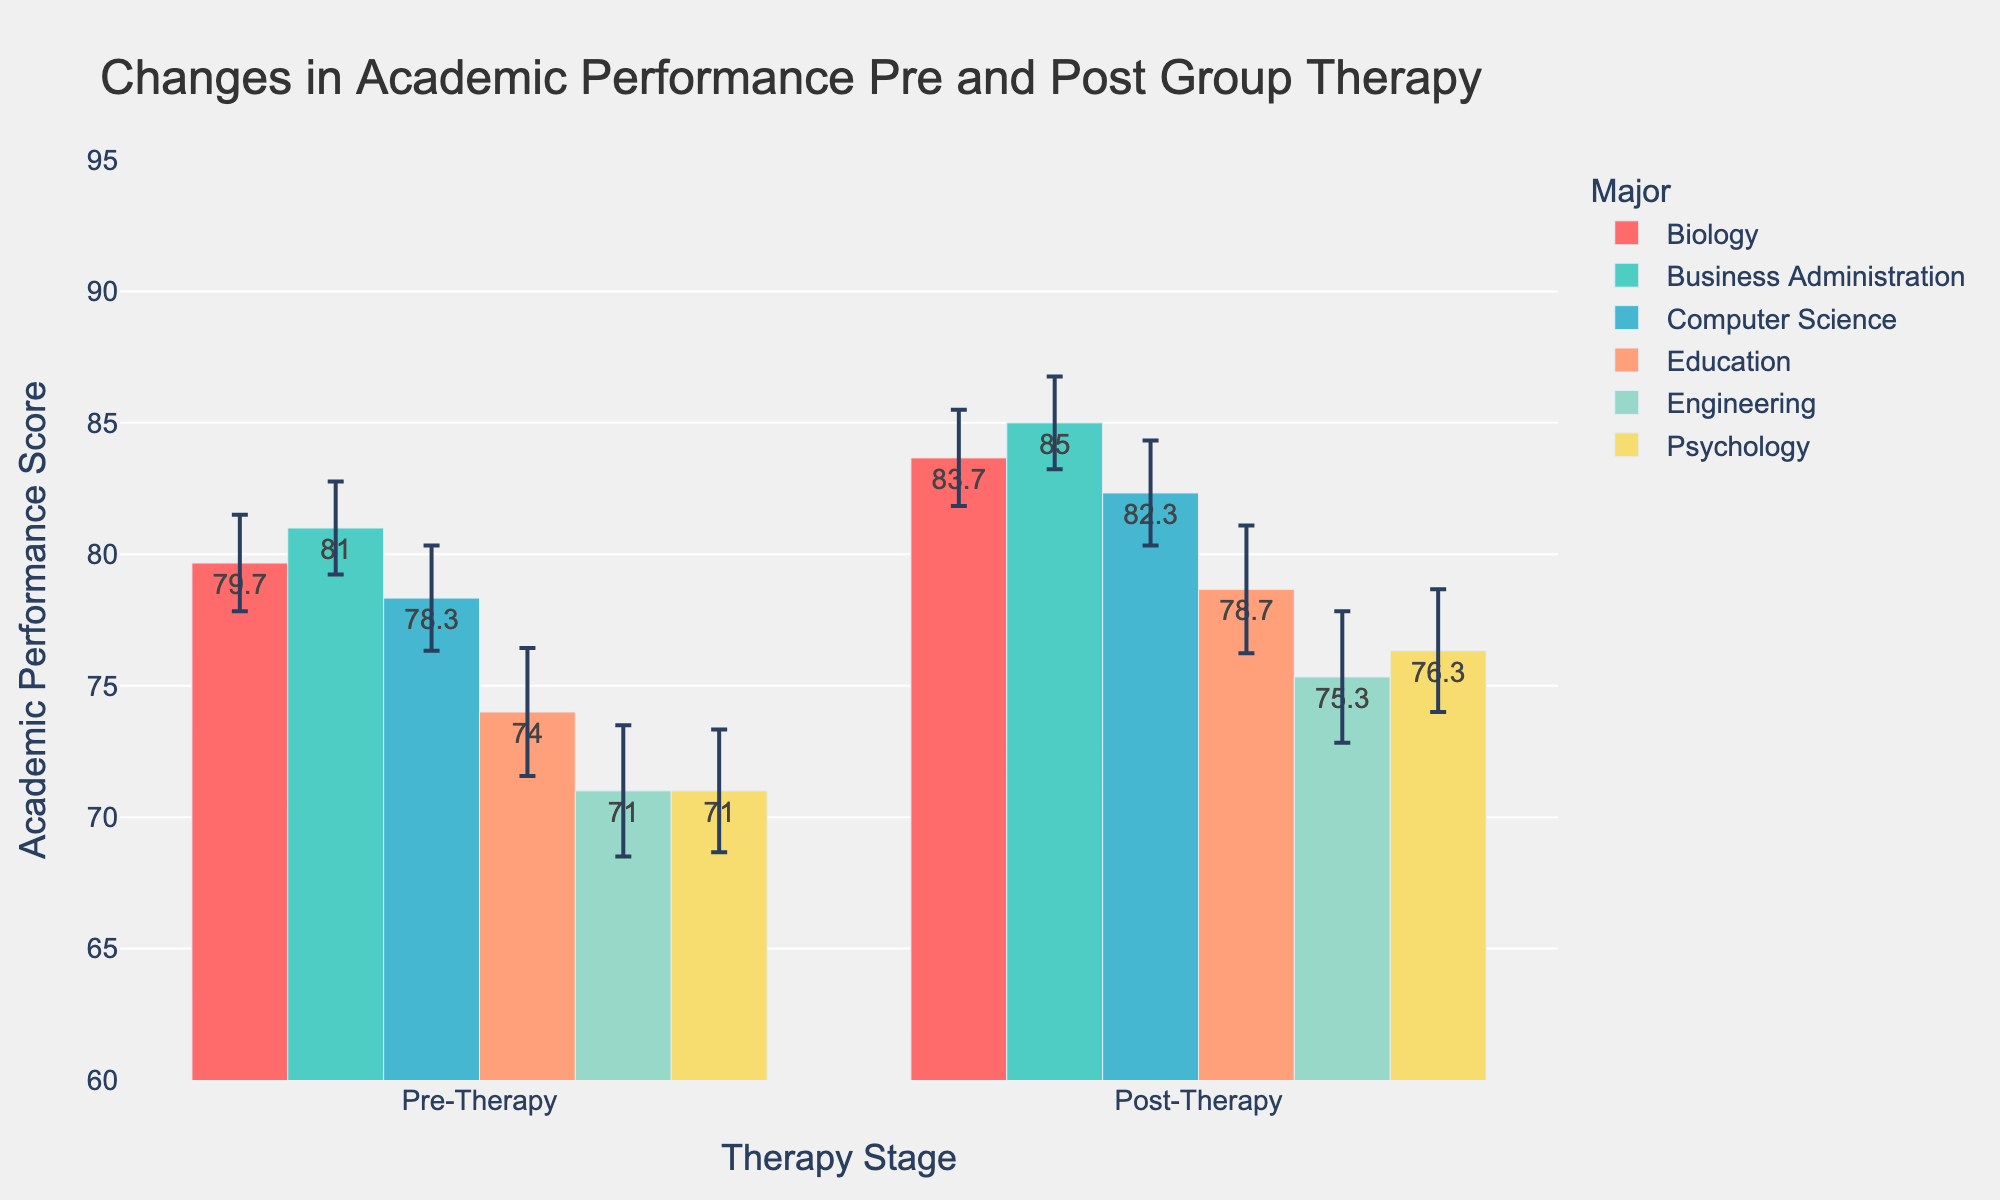What is the title of the plot? The title of the plot is at the top center and is designed to give an overview of the displayed information. It reads "Changes in Academic Performance Pre and Post Group Therapy".
Answer: Changes in Academic Performance Pre and Post Group Therapy What's the highest average post-therapy performance score by major? To determine the highest average post-therapy performance score, look at the bars representing the post-therapy performance for each major and identify the tallest one.
Answer: Business Administration How does the average performance change for Computer Science from pre-therapy to post-therapy? Compare the two bars for Computer Science: one for pre-therapy and one for post-therapy. Subtract the pre-therapy average from the post-therapy average to find the change.
Answer: +5 Which major shows the least improvement in average academic performance post-therapy? Identify the improvement by subtracting the pre-therapy average from the post-therapy average for each major. The major with the smallest positive difference shows the least improvement.
Answer: Engineering What is the average pre-therapy performance score of Psychology? Look at the height of the bar representing the pre-therapy performance for Psychology. This gives the average pre-therapy performance score.
Answer: 71 Which major has the largest error bar for post-therapy performance? Observe the error bars that represent the uncertainty in the measurements. Locate the major with the longest error bar in the post-therapy performance section.
Answer: Psychology Compare the improvement in average academic performance between Education and Biology. Which shows a greater improvement? Calculate the difference between post-therapy and pre-therapy performance for both Education and Biology. Compare the differences to see which is larger.
Answer: Education Are the error bars for pre-therapy and post-therapy performance for each major the same length? Examine the length of the error bars for both pre-therapy and post-therapy for each major. Note if the lengths are identical for each major.
Answer: Yes Which two majors have the closest post-therapy performance scores? Compare the heights of the post-therapy performance bars across the majors and identify the two that are closest in value.
Answer: Education and Engineering 